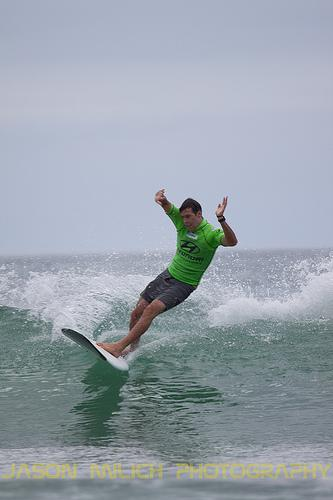Question: what is he on?
Choices:
A. Boat.
B. A surfboard.
C. Beach.
D. Ski lift.
Answer with the letter. Answer: B Question: where was this photo taken?
Choices:
A. On a mountain.
B. In a car.
C. At the zoo.
D. At a beach.
Answer with the letter. Answer: D Question: what is he doing?
Choices:
A. Skateboarding.
B. Swimming.
C. Surfing.
D. Playing soccer.
Answer with the letter. Answer: C 